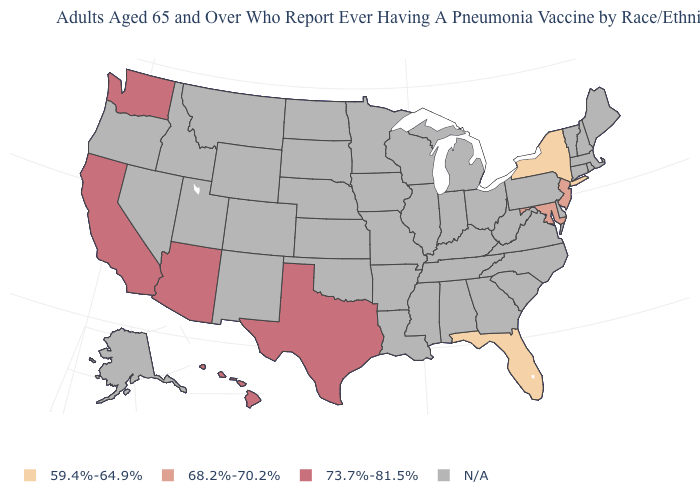How many symbols are there in the legend?
Quick response, please. 4. Among the states that border Oklahoma , which have the lowest value?
Give a very brief answer. Texas. What is the value of New Mexico?
Concise answer only. N/A. Does the map have missing data?
Answer briefly. Yes. Does the map have missing data?
Be succinct. Yes. What is the highest value in the USA?
Give a very brief answer. 73.7%-81.5%. Which states have the highest value in the USA?
Answer briefly. Arizona, California, Hawaii, Texas, Washington. Does Arizona have the lowest value in the USA?
Concise answer only. No. What is the value of Iowa?
Short answer required. N/A. What is the highest value in the Northeast ?
Short answer required. 68.2%-70.2%. What is the value of California?
Keep it brief. 73.7%-81.5%. Which states hav the highest value in the South?
Quick response, please. Texas. What is the value of Pennsylvania?
Short answer required. N/A. 